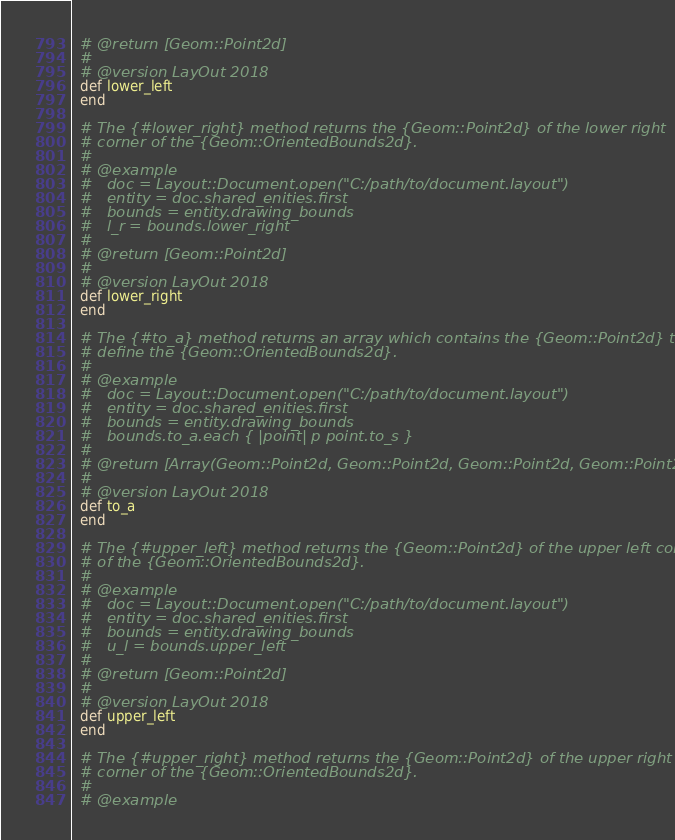Convert code to text. <code><loc_0><loc_0><loc_500><loc_500><_Ruby_>  # @return [Geom::Point2d]
  #
  # @version LayOut 2018
  def lower_left
  end

  # The {#lower_right} method returns the {Geom::Point2d} of the lower right
  # corner of the {Geom::OrientedBounds2d}.
  #
  # @example
  #   doc = Layout::Document.open("C:/path/to/document.layout")
  #   entity = doc.shared_enities.first
  #   bounds = entity.drawing_bounds
  #   l_r = bounds.lower_right
  #
  # @return [Geom::Point2d]
  #
  # @version LayOut 2018
  def lower_right
  end

  # The {#to_a} method returns an array which contains the {Geom::Point2d} that
  # define the {Geom::OrientedBounds2d}.
  #
  # @example
  #   doc = Layout::Document.open("C:/path/to/document.layout")
  #   entity = doc.shared_enities.first
  #   bounds = entity.drawing_bounds
  #   bounds.to_a.each { |point| p point.to_s }
  #
  # @return [Array(Geom::Point2d, Geom::Point2d, Geom::Point2d, Geom::Point2d)]
  #
  # @version LayOut 2018
  def to_a
  end

  # The {#upper_left} method returns the {Geom::Point2d} of the upper left corner
  # of the {Geom::OrientedBounds2d}.
  #
  # @example
  #   doc = Layout::Document.open("C:/path/to/document.layout")
  #   entity = doc.shared_enities.first
  #   bounds = entity.drawing_bounds
  #   u_l = bounds.upper_left
  #
  # @return [Geom::Point2d]
  #
  # @version LayOut 2018
  def upper_left
  end

  # The {#upper_right} method returns the {Geom::Point2d} of the upper right
  # corner of the {Geom::OrientedBounds2d}.
  #
  # @example</code> 